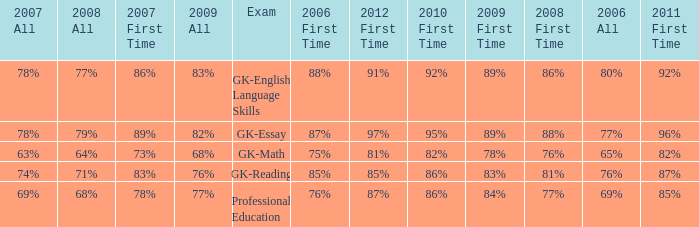What is the percentage for first time in 2012 when it was 82% for all in 2009? 97%. 